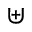Convert formula to latex. <formula><loc_0><loc_0><loc_500><loc_500>\uplus</formula> 